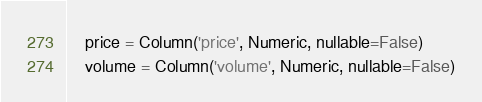<code> <loc_0><loc_0><loc_500><loc_500><_Python_>    price = Column('price', Numeric, nullable=False)
    volume = Column('volume', Numeric, nullable=False)

</code> 